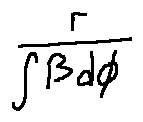Convert formula to latex. <formula><loc_0><loc_0><loc_500><loc_500>\frac { r } { \int \beta d \phi }</formula> 